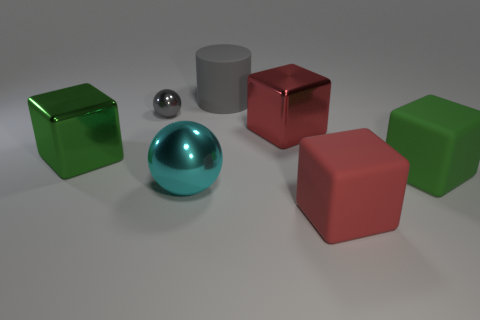Subtract all red matte cubes. How many cubes are left? 3 Subtract all green blocks. How many blocks are left? 2 Add 2 large red things. How many objects exist? 9 Subtract all balls. How many objects are left? 5 Subtract 1 cylinders. How many cylinders are left? 0 Subtract all blue spheres. Subtract all purple blocks. How many spheres are left? 2 Subtract all red blocks. How many gray balls are left? 1 Subtract all large green cubes. Subtract all cyan spheres. How many objects are left? 4 Add 7 large matte objects. How many large matte objects are left? 10 Add 6 red objects. How many red objects exist? 8 